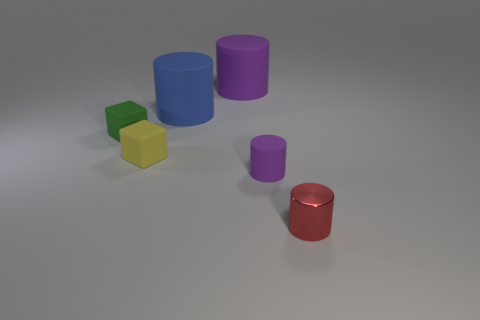Are there any cyan metal things of the same size as the red shiny object?
Provide a succinct answer. No. How many things are small blocks that are to the left of the yellow matte object or large rubber objects that are on the left side of the big purple thing?
Keep it short and to the point. 2. Do the matte cube behind the yellow rubber thing and the purple matte cylinder on the left side of the tiny purple matte cylinder have the same size?
Make the answer very short. No. There is a metallic object in front of the tiny green block; are there any tiny matte cylinders in front of it?
Offer a terse response. No. What number of tiny rubber objects are to the right of the tiny green thing?
Make the answer very short. 2. What number of other things are there of the same color as the metal object?
Offer a terse response. 0. Are there fewer large rubber things on the left side of the tiny yellow matte cube than metallic objects that are to the left of the small purple matte cylinder?
Your answer should be compact. No. How many things are tiny objects that are on the left side of the small yellow rubber cube or small purple things?
Make the answer very short. 2. There is a green thing; does it have the same size as the purple object that is in front of the tiny green cube?
Offer a very short reply. Yes. There is a blue thing that is the same shape as the small purple matte thing; what is its size?
Offer a terse response. Large. 